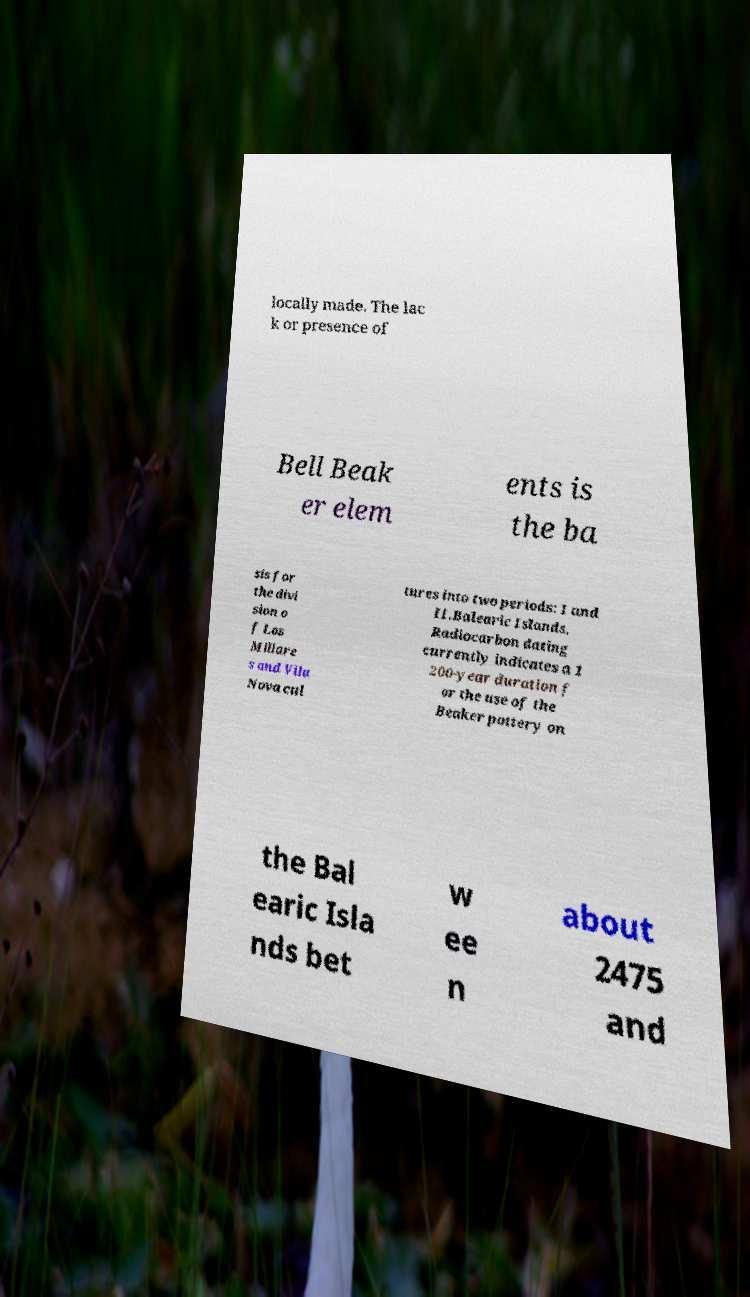Can you accurately transcribe the text from the provided image for me? locally made. The lac k or presence of Bell Beak er elem ents is the ba sis for the divi sion o f Los Millare s and Vila Nova cul tures into two periods: I and II.Balearic Islands. Radiocarbon dating currently indicates a 1 200-year duration f or the use of the Beaker pottery on the Bal earic Isla nds bet w ee n about 2475 and 